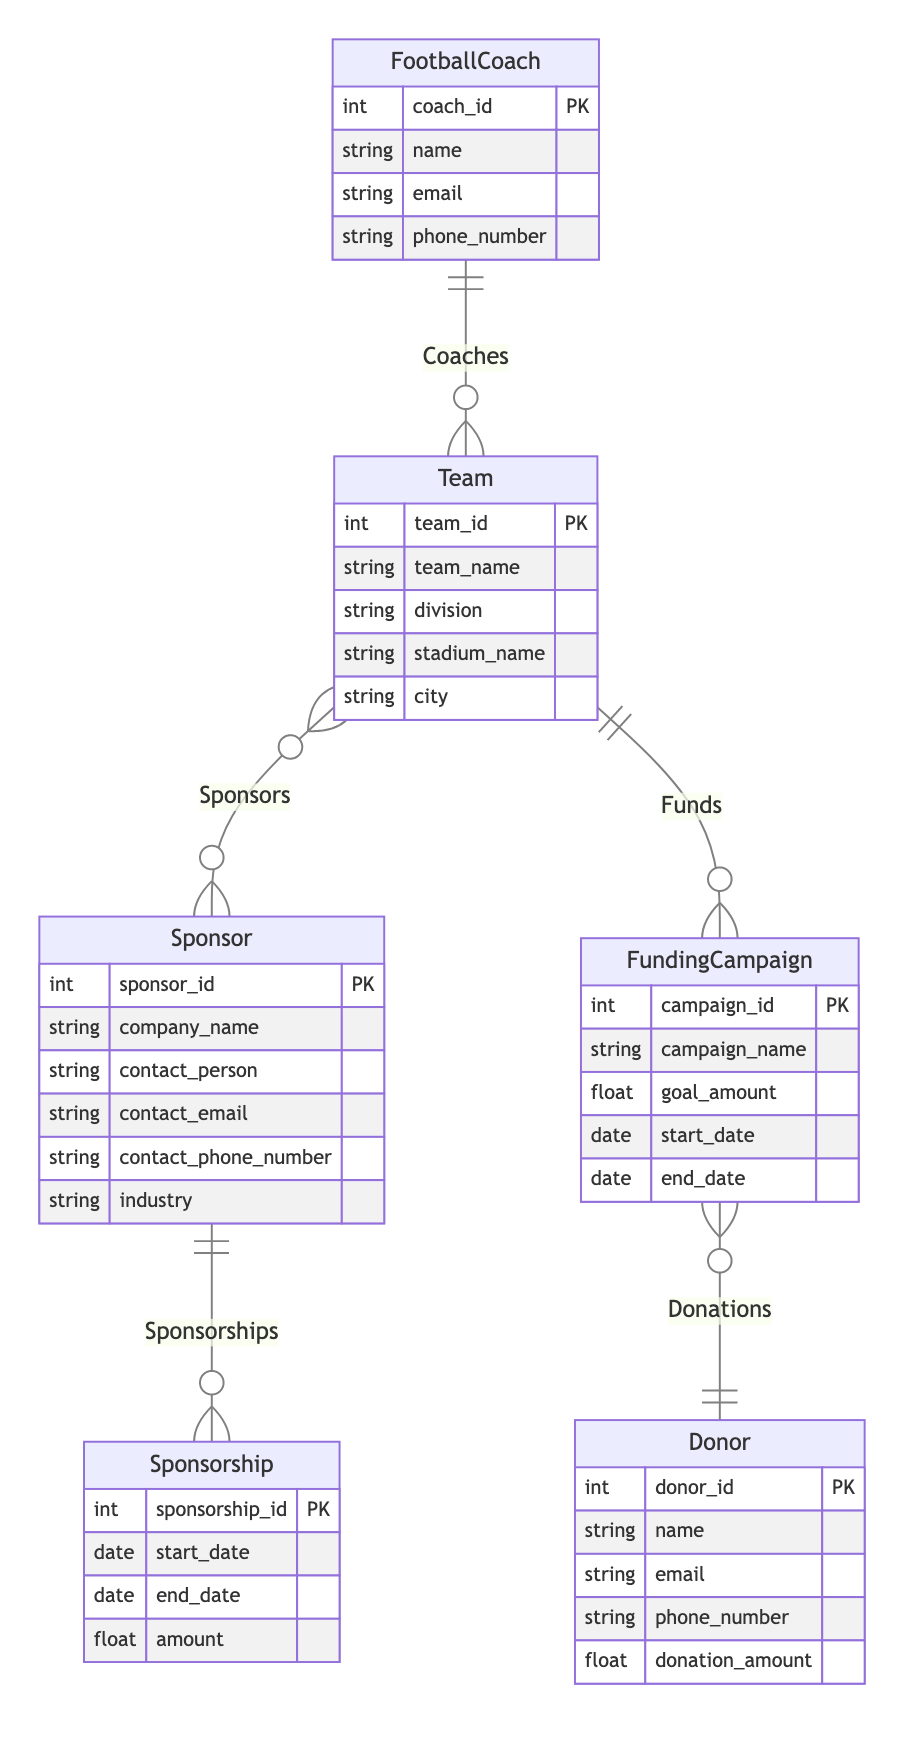What is the primary key of the Sponsor entity? The primary key of the Sponsor entity is sponsor_id, which is used to uniquely identify each sponsor in the diagram.
Answer: sponsor_id How many entities are present in the diagram? The diagram contains six entities: FootballCoach, Team, Sponsorship, Sponsor, FundingCampaign, and Donor. By counting them, we can determine the total number of entities.
Answer: 6 What is the relationship type between Team and Sponsor? The relationship type between Team and Sponsor is M-M, indicating that multiple teams can have multiple sponsors, and each sponsor can support multiple teams.
Answer: M-M Which entity is linked to FundingCampaign? The FundingCampaign is linked to the Team entity, as indicated by the relationship named "Funds" in the diagram.
Answer: Team How many maximum sponsors can a single team have? There is a many-to-many relationship between Team and Sponsor, which means a single team can have multiple sponsors without a specific limit defined in the diagram. However, since it's M-M, we can infer that a team can have many sponsors.
Answer: Many What is the relationship between Sponsorship and Sponsor? The relationship between Sponsorship and Sponsor is M-1, meaning that many sponsorships can be associated with one sponsor, while each sponsorship links back to only one sponsor.
Answer: M-1 What is the maximum number of funding campaigns that a single donor can contribute to? Each donor can contribute to many funding campaigns indicated by the M-1 relationship between Donor and FundingCampaign. Therefore, it can be inferred that a single donor can contribute to multiple campaigns.
Answer: Many What is the primary key of the Team entity? The primary key of the Team entity is team_id, which uniquely identifies each team within the data structure of the diagram.
Answer: team_id Which entity is at the start of the "Donations" relationship? The entity at the start of the "Donations" relationship is Donor, as indicated by the M-1 relationship, which means that multiple donations can be made by one donor to a funding campaign.
Answer: Donor 